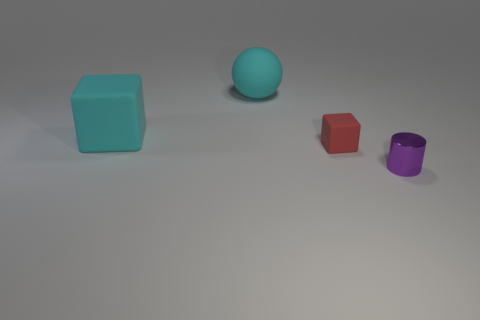Add 4 small purple shiny cylinders. How many objects exist? 8 Subtract all cylinders. How many objects are left? 3 Add 2 purple shiny cylinders. How many purple shiny cylinders are left? 3 Add 4 big red objects. How many big red objects exist? 4 Subtract 1 red blocks. How many objects are left? 3 Subtract all cyan spheres. Subtract all tiny metal cylinders. How many objects are left? 2 